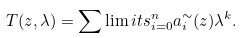<formula> <loc_0><loc_0><loc_500><loc_500>T ( z , \lambda ) = \sum \lim i t s _ { i = 0 } ^ { n } a ^ { \sim } _ { i } ( z ) \lambda ^ { k } .</formula> 